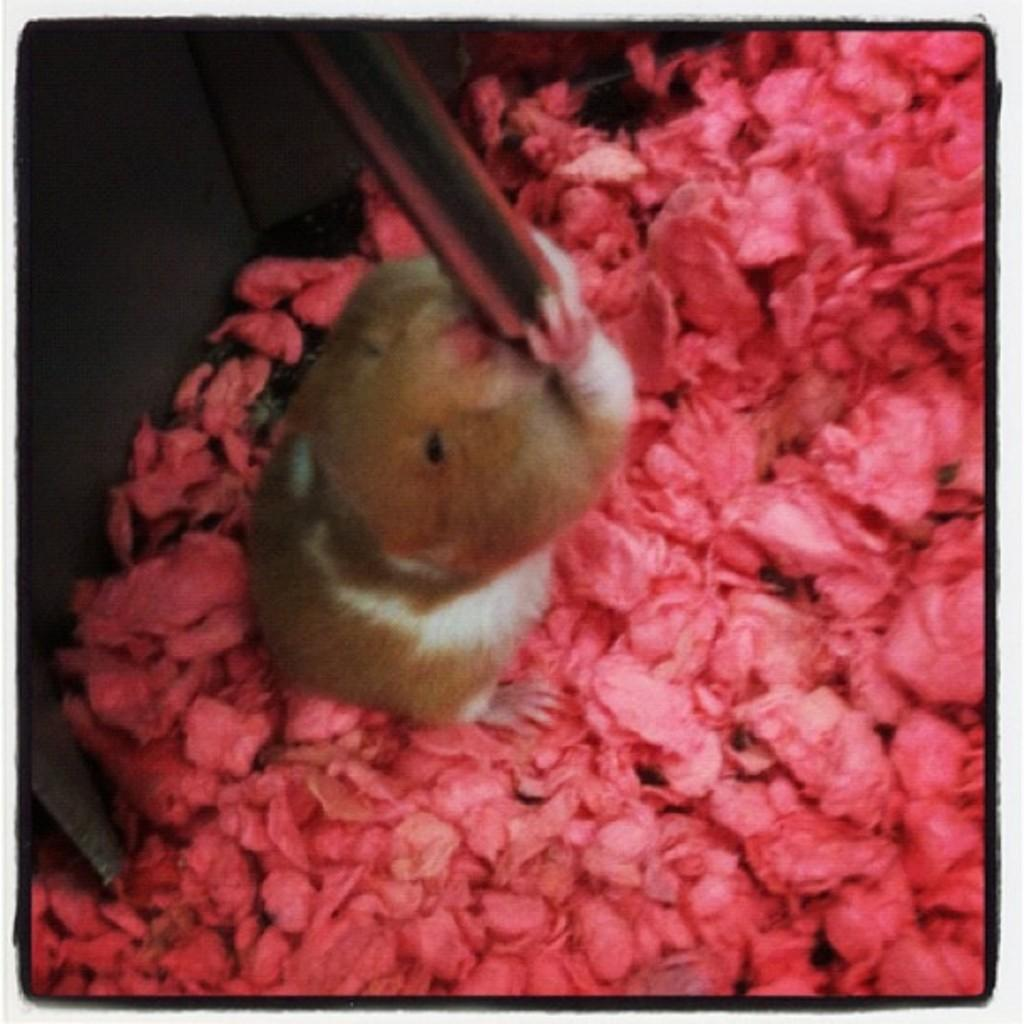What is the main subject in the center of the image? There is a rat in the center of the image. What can be seen at the bottom of the image? There are objects at the bottom of the image. What is visible in the background of the image? There is a wall in the background of the image. What type of car is parked next to the rat in the image? There is no car present in the image; it features a rat and other objects. How does the rat affect the temper of the scarecrow in the image? There is no scarecrow present in the image, so it is not possible to determine how the rat might affect its temper. 